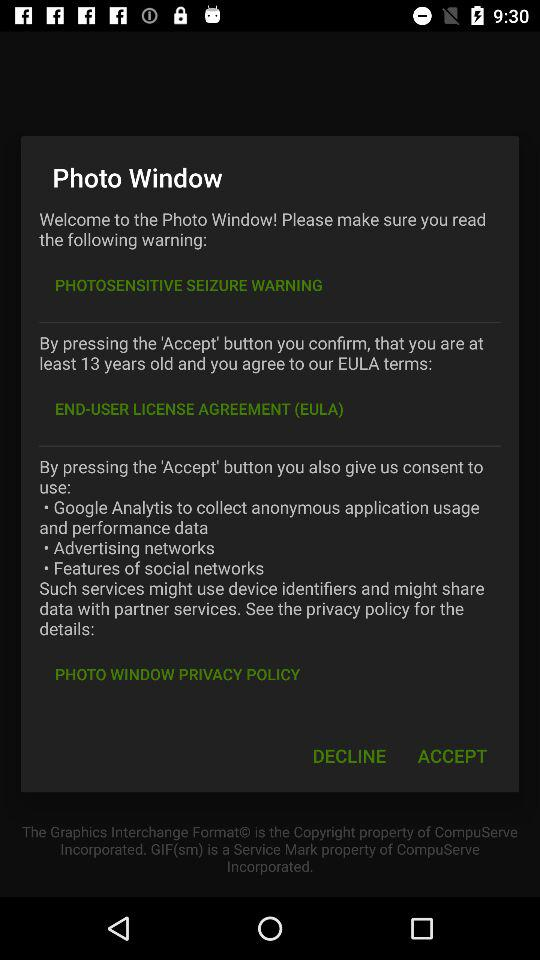What is the mentioned age? The mentioned age is at least 13 years old. 